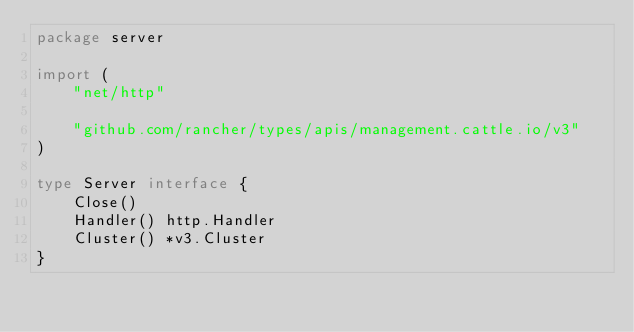Convert code to text. <code><loc_0><loc_0><loc_500><loc_500><_Go_>package server

import (
	"net/http"

	"github.com/rancher/types/apis/management.cattle.io/v3"
)

type Server interface {
	Close()
	Handler() http.Handler
	Cluster() *v3.Cluster
}
</code> 